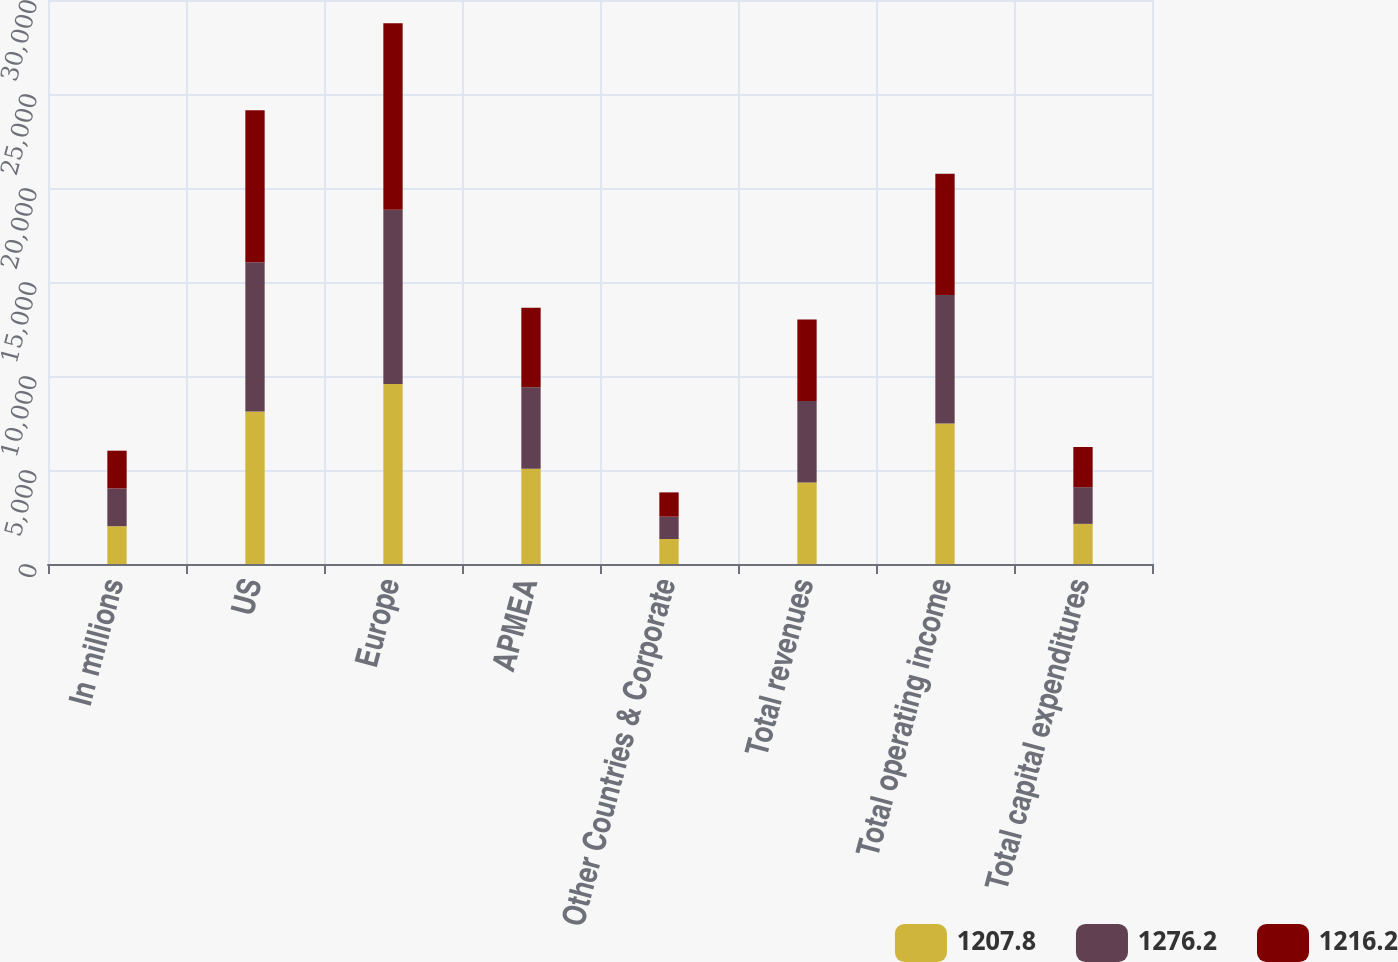Convert chart to OTSL. <chart><loc_0><loc_0><loc_500><loc_500><stacked_bar_chart><ecel><fcel>In millions<fcel>US<fcel>Europe<fcel>APMEA<fcel>Other Countries & Corporate<fcel>Total revenues<fcel>Total operating income<fcel>Total capital expenditures<nl><fcel>1207.8<fcel>2010<fcel>8111.6<fcel>9569.2<fcel>5065.5<fcel>1328.3<fcel>4337<fcel>7473.1<fcel>2135.5<nl><fcel>1276.2<fcel>2009<fcel>7943.8<fcel>9273.8<fcel>4337<fcel>1190.1<fcel>4337<fcel>6841<fcel>1952.1<nl><fcel>1216.2<fcel>2008<fcel>8078.3<fcel>9922.9<fcel>4230.8<fcel>1290.4<fcel>4337<fcel>6442.9<fcel>2135.7<nl></chart> 